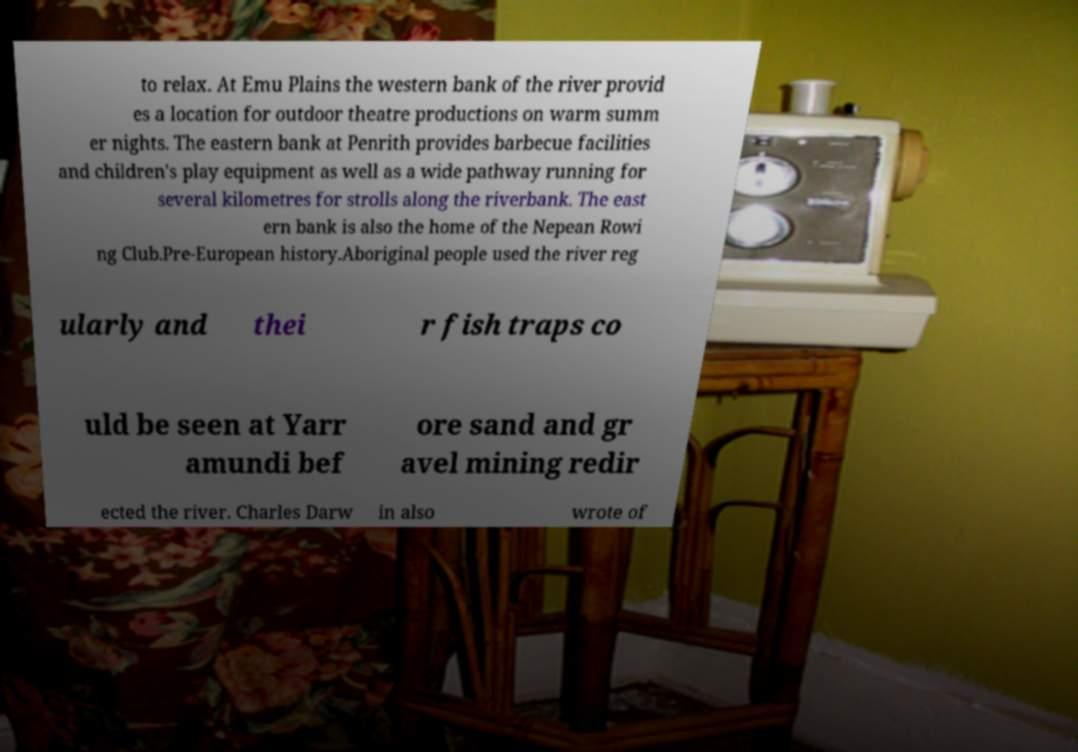Could you extract and type out the text from this image? to relax. At Emu Plains the western bank of the river provid es a location for outdoor theatre productions on warm summ er nights. The eastern bank at Penrith provides barbecue facilities and children's play equipment as well as a wide pathway running for several kilometres for strolls along the riverbank. The east ern bank is also the home of the Nepean Rowi ng Club.Pre-European history.Aboriginal people used the river reg ularly and thei r fish traps co uld be seen at Yarr amundi bef ore sand and gr avel mining redir ected the river. Charles Darw in also wrote of 